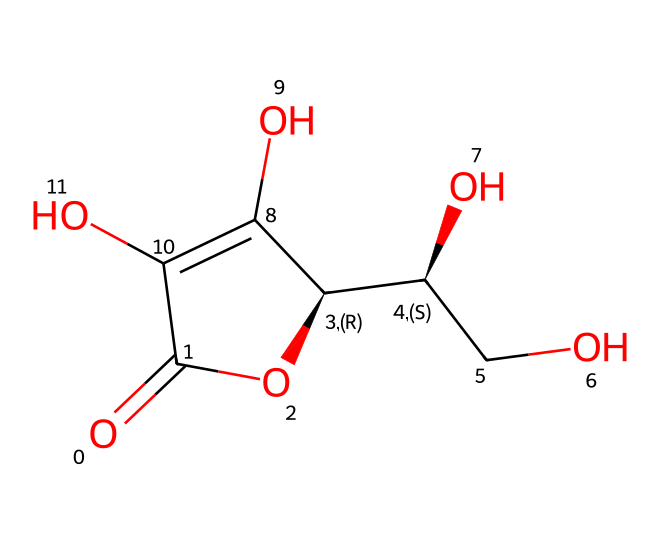What is the molecular formula of ascorbic acid? The SMILES representation indicates the types and numbers of atoms present in the structure. By analyzing the structure, we find that there are 6 carbon atoms, 8 hydrogen atoms, and 6 oxygen atoms. Therefore, the molecular formula is C6H8O6.
Answer: C6H8O6 How many hydroxyl groups are present in ascorbic acid? The structure contains hydroxyl groups (-OH). By visually identifying the relevant parts in the chemical structure, I can count 4 distinct -OH groups attached to the carbon atoms.
Answer: 4 What type of vitamin is ascorbic acid? Ascorbic acid is known as Vitamin C, which is a water-soluble vitamin crucial for various bodily functions. This classification is based on its solubility in water.
Answer: Vitamin C Does ascorbic acid contain any rings in its structure? The structure shows a cyclic component. Specifically, the SMILES reveals a 6-membered ring formed by the carbon atoms and oxygen atoms. This cyclic structure is typical of ascorbic acid.
Answer: Yes In what common foods is ascorbic acid primarily found? Ascorbic acid is primarily found in citrus fruits such as oranges, lemons, and grapefruits. This common knowledge is associated with the high vitamin C content in these fruits.
Answer: Citrus fruits What is the significance of ascorbic acid for vocal health? Ascorbic acid plays a role in maintaining healthy vocal cords, as it contributes to tissue repair, reduces inflammation, and helps with overall immune function. This is particularly relevant for musicians who rely on their voice.
Answer: Tissue repair 